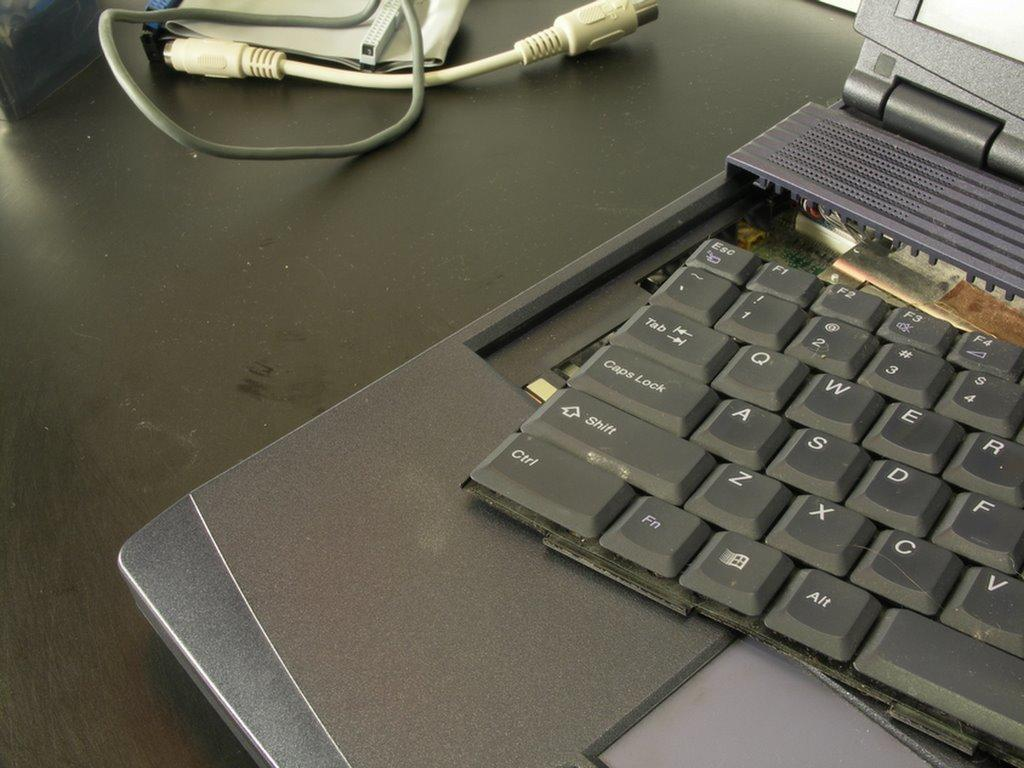<image>
Render a clear and concise summary of the photo. Broken black laptopwith the ctrl key near the bottom left. 